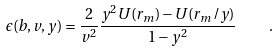<formula> <loc_0><loc_0><loc_500><loc_500>\epsilon ( b , v , y ) = \frac { 2 } { v ^ { 2 } } \frac { y ^ { 2 } U ( r _ { m } ) - U ( r _ { m } / y ) } { 1 - y ^ { 2 } } \quad .</formula> 